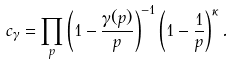<formula> <loc_0><loc_0><loc_500><loc_500>c _ { \gamma } = \prod _ { p } \left ( 1 - \frac { \gamma ( p ) } { p } \right ) ^ { - 1 } \left ( 1 - \frac { 1 } { p } \right ) ^ { \kappa } .</formula> 